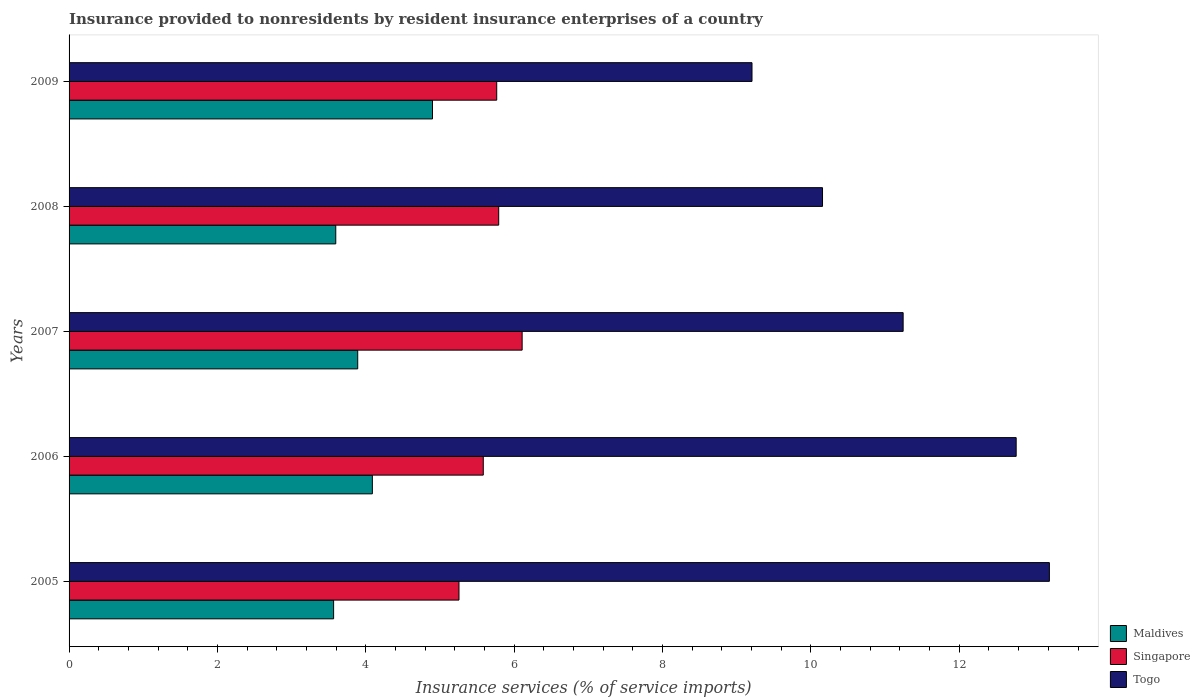How many bars are there on the 2nd tick from the top?
Offer a very short reply. 3. How many bars are there on the 2nd tick from the bottom?
Ensure brevity in your answer.  3. In how many cases, is the number of bars for a given year not equal to the number of legend labels?
Your response must be concise. 0. What is the insurance provided to nonresidents in Togo in 2005?
Your response must be concise. 13.21. Across all years, what is the maximum insurance provided to nonresidents in Maldives?
Make the answer very short. 4.9. Across all years, what is the minimum insurance provided to nonresidents in Maldives?
Ensure brevity in your answer.  3.57. What is the total insurance provided to nonresidents in Maldives in the graph?
Offer a terse response. 20.04. What is the difference between the insurance provided to nonresidents in Singapore in 2006 and that in 2008?
Give a very brief answer. -0.21. What is the difference between the insurance provided to nonresidents in Singapore in 2009 and the insurance provided to nonresidents in Togo in 2008?
Provide a short and direct response. -4.39. What is the average insurance provided to nonresidents in Maldives per year?
Provide a short and direct response. 4.01. In the year 2008, what is the difference between the insurance provided to nonresidents in Maldives and insurance provided to nonresidents in Togo?
Ensure brevity in your answer.  -6.56. What is the ratio of the insurance provided to nonresidents in Singapore in 2006 to that in 2008?
Offer a terse response. 0.96. Is the insurance provided to nonresidents in Maldives in 2005 less than that in 2006?
Make the answer very short. Yes. Is the difference between the insurance provided to nonresidents in Maldives in 2005 and 2006 greater than the difference between the insurance provided to nonresidents in Togo in 2005 and 2006?
Ensure brevity in your answer.  No. What is the difference between the highest and the second highest insurance provided to nonresidents in Singapore?
Your answer should be compact. 0.32. What is the difference between the highest and the lowest insurance provided to nonresidents in Maldives?
Make the answer very short. 1.33. In how many years, is the insurance provided to nonresidents in Singapore greater than the average insurance provided to nonresidents in Singapore taken over all years?
Your answer should be compact. 3. Is the sum of the insurance provided to nonresidents in Maldives in 2007 and 2008 greater than the maximum insurance provided to nonresidents in Singapore across all years?
Make the answer very short. Yes. What does the 2nd bar from the top in 2008 represents?
Make the answer very short. Singapore. What does the 1st bar from the bottom in 2007 represents?
Your response must be concise. Maldives. Is it the case that in every year, the sum of the insurance provided to nonresidents in Togo and insurance provided to nonresidents in Singapore is greater than the insurance provided to nonresidents in Maldives?
Your response must be concise. Yes. How many bars are there?
Give a very brief answer. 15. Are all the bars in the graph horizontal?
Keep it short and to the point. Yes. Are the values on the major ticks of X-axis written in scientific E-notation?
Give a very brief answer. No. Where does the legend appear in the graph?
Offer a very short reply. Bottom right. How many legend labels are there?
Provide a succinct answer. 3. What is the title of the graph?
Provide a short and direct response. Insurance provided to nonresidents by resident insurance enterprises of a country. Does "Sub-Saharan Africa (all income levels)" appear as one of the legend labels in the graph?
Your response must be concise. No. What is the label or title of the X-axis?
Give a very brief answer. Insurance services (% of service imports). What is the label or title of the Y-axis?
Ensure brevity in your answer.  Years. What is the Insurance services (% of service imports) of Maldives in 2005?
Your answer should be compact. 3.57. What is the Insurance services (% of service imports) of Singapore in 2005?
Make the answer very short. 5.26. What is the Insurance services (% of service imports) in Togo in 2005?
Offer a terse response. 13.21. What is the Insurance services (% of service imports) of Maldives in 2006?
Keep it short and to the point. 4.09. What is the Insurance services (% of service imports) of Singapore in 2006?
Give a very brief answer. 5.58. What is the Insurance services (% of service imports) of Togo in 2006?
Your answer should be compact. 12.77. What is the Insurance services (% of service imports) in Maldives in 2007?
Offer a terse response. 3.89. What is the Insurance services (% of service imports) in Singapore in 2007?
Offer a very short reply. 6.11. What is the Insurance services (% of service imports) in Togo in 2007?
Your answer should be very brief. 11.24. What is the Insurance services (% of service imports) in Maldives in 2008?
Make the answer very short. 3.59. What is the Insurance services (% of service imports) of Singapore in 2008?
Keep it short and to the point. 5.79. What is the Insurance services (% of service imports) in Togo in 2008?
Offer a terse response. 10.16. What is the Insurance services (% of service imports) in Maldives in 2009?
Your answer should be very brief. 4.9. What is the Insurance services (% of service imports) of Singapore in 2009?
Provide a short and direct response. 5.76. What is the Insurance services (% of service imports) in Togo in 2009?
Offer a terse response. 9.21. Across all years, what is the maximum Insurance services (% of service imports) in Maldives?
Give a very brief answer. 4.9. Across all years, what is the maximum Insurance services (% of service imports) of Singapore?
Give a very brief answer. 6.11. Across all years, what is the maximum Insurance services (% of service imports) in Togo?
Offer a terse response. 13.21. Across all years, what is the minimum Insurance services (% of service imports) of Maldives?
Ensure brevity in your answer.  3.57. Across all years, what is the minimum Insurance services (% of service imports) in Singapore?
Offer a very short reply. 5.26. Across all years, what is the minimum Insurance services (% of service imports) in Togo?
Your answer should be very brief. 9.21. What is the total Insurance services (% of service imports) in Maldives in the graph?
Ensure brevity in your answer.  20.04. What is the total Insurance services (% of service imports) in Singapore in the graph?
Offer a terse response. 28.5. What is the total Insurance services (% of service imports) of Togo in the graph?
Give a very brief answer. 56.58. What is the difference between the Insurance services (% of service imports) of Maldives in 2005 and that in 2006?
Your response must be concise. -0.52. What is the difference between the Insurance services (% of service imports) in Singapore in 2005 and that in 2006?
Your answer should be compact. -0.33. What is the difference between the Insurance services (% of service imports) in Togo in 2005 and that in 2006?
Your answer should be very brief. 0.45. What is the difference between the Insurance services (% of service imports) in Maldives in 2005 and that in 2007?
Provide a short and direct response. -0.33. What is the difference between the Insurance services (% of service imports) in Singapore in 2005 and that in 2007?
Your response must be concise. -0.85. What is the difference between the Insurance services (% of service imports) of Togo in 2005 and that in 2007?
Your answer should be compact. 1.97. What is the difference between the Insurance services (% of service imports) in Maldives in 2005 and that in 2008?
Your answer should be very brief. -0.03. What is the difference between the Insurance services (% of service imports) of Singapore in 2005 and that in 2008?
Your answer should be compact. -0.54. What is the difference between the Insurance services (% of service imports) in Togo in 2005 and that in 2008?
Keep it short and to the point. 3.06. What is the difference between the Insurance services (% of service imports) in Maldives in 2005 and that in 2009?
Keep it short and to the point. -1.33. What is the difference between the Insurance services (% of service imports) of Singapore in 2005 and that in 2009?
Provide a succinct answer. -0.51. What is the difference between the Insurance services (% of service imports) in Togo in 2005 and that in 2009?
Provide a succinct answer. 4.01. What is the difference between the Insurance services (% of service imports) in Maldives in 2006 and that in 2007?
Offer a very short reply. 0.2. What is the difference between the Insurance services (% of service imports) in Singapore in 2006 and that in 2007?
Offer a terse response. -0.52. What is the difference between the Insurance services (% of service imports) in Togo in 2006 and that in 2007?
Offer a very short reply. 1.52. What is the difference between the Insurance services (% of service imports) of Maldives in 2006 and that in 2008?
Provide a short and direct response. 0.49. What is the difference between the Insurance services (% of service imports) of Singapore in 2006 and that in 2008?
Give a very brief answer. -0.21. What is the difference between the Insurance services (% of service imports) in Togo in 2006 and that in 2008?
Provide a succinct answer. 2.61. What is the difference between the Insurance services (% of service imports) in Maldives in 2006 and that in 2009?
Provide a short and direct response. -0.81. What is the difference between the Insurance services (% of service imports) of Singapore in 2006 and that in 2009?
Your answer should be compact. -0.18. What is the difference between the Insurance services (% of service imports) of Togo in 2006 and that in 2009?
Keep it short and to the point. 3.56. What is the difference between the Insurance services (% of service imports) of Maldives in 2007 and that in 2008?
Ensure brevity in your answer.  0.3. What is the difference between the Insurance services (% of service imports) in Singapore in 2007 and that in 2008?
Make the answer very short. 0.32. What is the difference between the Insurance services (% of service imports) in Togo in 2007 and that in 2008?
Your answer should be compact. 1.09. What is the difference between the Insurance services (% of service imports) in Maldives in 2007 and that in 2009?
Offer a terse response. -1.01. What is the difference between the Insurance services (% of service imports) of Singapore in 2007 and that in 2009?
Your answer should be very brief. 0.34. What is the difference between the Insurance services (% of service imports) of Togo in 2007 and that in 2009?
Provide a succinct answer. 2.04. What is the difference between the Insurance services (% of service imports) in Maldives in 2008 and that in 2009?
Your answer should be very brief. -1.3. What is the difference between the Insurance services (% of service imports) of Singapore in 2008 and that in 2009?
Offer a very short reply. 0.03. What is the difference between the Insurance services (% of service imports) of Togo in 2008 and that in 2009?
Provide a short and direct response. 0.95. What is the difference between the Insurance services (% of service imports) in Maldives in 2005 and the Insurance services (% of service imports) in Singapore in 2006?
Your response must be concise. -2.02. What is the difference between the Insurance services (% of service imports) of Maldives in 2005 and the Insurance services (% of service imports) of Togo in 2006?
Your answer should be very brief. -9.2. What is the difference between the Insurance services (% of service imports) of Singapore in 2005 and the Insurance services (% of service imports) of Togo in 2006?
Make the answer very short. -7.51. What is the difference between the Insurance services (% of service imports) of Maldives in 2005 and the Insurance services (% of service imports) of Singapore in 2007?
Offer a very short reply. -2.54. What is the difference between the Insurance services (% of service imports) of Maldives in 2005 and the Insurance services (% of service imports) of Togo in 2007?
Offer a very short reply. -7.68. What is the difference between the Insurance services (% of service imports) of Singapore in 2005 and the Insurance services (% of service imports) of Togo in 2007?
Provide a short and direct response. -5.99. What is the difference between the Insurance services (% of service imports) in Maldives in 2005 and the Insurance services (% of service imports) in Singapore in 2008?
Keep it short and to the point. -2.23. What is the difference between the Insurance services (% of service imports) in Maldives in 2005 and the Insurance services (% of service imports) in Togo in 2008?
Give a very brief answer. -6.59. What is the difference between the Insurance services (% of service imports) in Singapore in 2005 and the Insurance services (% of service imports) in Togo in 2008?
Your answer should be compact. -4.9. What is the difference between the Insurance services (% of service imports) of Maldives in 2005 and the Insurance services (% of service imports) of Singapore in 2009?
Your answer should be very brief. -2.2. What is the difference between the Insurance services (% of service imports) in Maldives in 2005 and the Insurance services (% of service imports) in Togo in 2009?
Your answer should be compact. -5.64. What is the difference between the Insurance services (% of service imports) of Singapore in 2005 and the Insurance services (% of service imports) of Togo in 2009?
Your answer should be compact. -3.95. What is the difference between the Insurance services (% of service imports) in Maldives in 2006 and the Insurance services (% of service imports) in Singapore in 2007?
Ensure brevity in your answer.  -2.02. What is the difference between the Insurance services (% of service imports) in Maldives in 2006 and the Insurance services (% of service imports) in Togo in 2007?
Provide a short and direct response. -7.15. What is the difference between the Insurance services (% of service imports) in Singapore in 2006 and the Insurance services (% of service imports) in Togo in 2007?
Your answer should be compact. -5.66. What is the difference between the Insurance services (% of service imports) of Maldives in 2006 and the Insurance services (% of service imports) of Singapore in 2008?
Offer a terse response. -1.7. What is the difference between the Insurance services (% of service imports) of Maldives in 2006 and the Insurance services (% of service imports) of Togo in 2008?
Ensure brevity in your answer.  -6.07. What is the difference between the Insurance services (% of service imports) in Singapore in 2006 and the Insurance services (% of service imports) in Togo in 2008?
Your response must be concise. -4.57. What is the difference between the Insurance services (% of service imports) in Maldives in 2006 and the Insurance services (% of service imports) in Singapore in 2009?
Offer a terse response. -1.68. What is the difference between the Insurance services (% of service imports) of Maldives in 2006 and the Insurance services (% of service imports) of Togo in 2009?
Your answer should be compact. -5.12. What is the difference between the Insurance services (% of service imports) of Singapore in 2006 and the Insurance services (% of service imports) of Togo in 2009?
Your response must be concise. -3.62. What is the difference between the Insurance services (% of service imports) of Maldives in 2007 and the Insurance services (% of service imports) of Singapore in 2008?
Provide a short and direct response. -1.9. What is the difference between the Insurance services (% of service imports) in Maldives in 2007 and the Insurance services (% of service imports) in Togo in 2008?
Give a very brief answer. -6.27. What is the difference between the Insurance services (% of service imports) in Singapore in 2007 and the Insurance services (% of service imports) in Togo in 2008?
Your answer should be very brief. -4.05. What is the difference between the Insurance services (% of service imports) in Maldives in 2007 and the Insurance services (% of service imports) in Singapore in 2009?
Keep it short and to the point. -1.87. What is the difference between the Insurance services (% of service imports) of Maldives in 2007 and the Insurance services (% of service imports) of Togo in 2009?
Provide a short and direct response. -5.31. What is the difference between the Insurance services (% of service imports) in Singapore in 2007 and the Insurance services (% of service imports) in Togo in 2009?
Provide a short and direct response. -3.1. What is the difference between the Insurance services (% of service imports) of Maldives in 2008 and the Insurance services (% of service imports) of Singapore in 2009?
Your response must be concise. -2.17. What is the difference between the Insurance services (% of service imports) of Maldives in 2008 and the Insurance services (% of service imports) of Togo in 2009?
Your answer should be compact. -5.61. What is the difference between the Insurance services (% of service imports) of Singapore in 2008 and the Insurance services (% of service imports) of Togo in 2009?
Offer a very short reply. -3.41. What is the average Insurance services (% of service imports) of Maldives per year?
Your answer should be compact. 4.01. What is the average Insurance services (% of service imports) in Singapore per year?
Keep it short and to the point. 5.7. What is the average Insurance services (% of service imports) of Togo per year?
Your response must be concise. 11.32. In the year 2005, what is the difference between the Insurance services (% of service imports) of Maldives and Insurance services (% of service imports) of Singapore?
Give a very brief answer. -1.69. In the year 2005, what is the difference between the Insurance services (% of service imports) of Maldives and Insurance services (% of service imports) of Togo?
Your response must be concise. -9.65. In the year 2005, what is the difference between the Insurance services (% of service imports) of Singapore and Insurance services (% of service imports) of Togo?
Provide a short and direct response. -7.96. In the year 2006, what is the difference between the Insurance services (% of service imports) of Maldives and Insurance services (% of service imports) of Singapore?
Your answer should be compact. -1.5. In the year 2006, what is the difference between the Insurance services (% of service imports) in Maldives and Insurance services (% of service imports) in Togo?
Make the answer very short. -8.68. In the year 2006, what is the difference between the Insurance services (% of service imports) in Singapore and Insurance services (% of service imports) in Togo?
Keep it short and to the point. -7.18. In the year 2007, what is the difference between the Insurance services (% of service imports) of Maldives and Insurance services (% of service imports) of Singapore?
Offer a very short reply. -2.22. In the year 2007, what is the difference between the Insurance services (% of service imports) of Maldives and Insurance services (% of service imports) of Togo?
Your answer should be compact. -7.35. In the year 2007, what is the difference between the Insurance services (% of service imports) of Singapore and Insurance services (% of service imports) of Togo?
Make the answer very short. -5.14. In the year 2008, what is the difference between the Insurance services (% of service imports) in Maldives and Insurance services (% of service imports) in Singapore?
Your response must be concise. -2.2. In the year 2008, what is the difference between the Insurance services (% of service imports) of Maldives and Insurance services (% of service imports) of Togo?
Your response must be concise. -6.56. In the year 2008, what is the difference between the Insurance services (% of service imports) in Singapore and Insurance services (% of service imports) in Togo?
Make the answer very short. -4.36. In the year 2009, what is the difference between the Insurance services (% of service imports) in Maldives and Insurance services (% of service imports) in Singapore?
Provide a short and direct response. -0.87. In the year 2009, what is the difference between the Insurance services (% of service imports) in Maldives and Insurance services (% of service imports) in Togo?
Your answer should be compact. -4.31. In the year 2009, what is the difference between the Insurance services (% of service imports) in Singapore and Insurance services (% of service imports) in Togo?
Offer a terse response. -3.44. What is the ratio of the Insurance services (% of service imports) in Maldives in 2005 to that in 2006?
Offer a very short reply. 0.87. What is the ratio of the Insurance services (% of service imports) in Singapore in 2005 to that in 2006?
Offer a very short reply. 0.94. What is the ratio of the Insurance services (% of service imports) of Togo in 2005 to that in 2006?
Make the answer very short. 1.04. What is the ratio of the Insurance services (% of service imports) of Maldives in 2005 to that in 2007?
Your answer should be very brief. 0.92. What is the ratio of the Insurance services (% of service imports) in Singapore in 2005 to that in 2007?
Provide a short and direct response. 0.86. What is the ratio of the Insurance services (% of service imports) in Togo in 2005 to that in 2007?
Ensure brevity in your answer.  1.18. What is the ratio of the Insurance services (% of service imports) of Maldives in 2005 to that in 2008?
Your response must be concise. 0.99. What is the ratio of the Insurance services (% of service imports) in Singapore in 2005 to that in 2008?
Offer a terse response. 0.91. What is the ratio of the Insurance services (% of service imports) of Togo in 2005 to that in 2008?
Your answer should be compact. 1.3. What is the ratio of the Insurance services (% of service imports) of Maldives in 2005 to that in 2009?
Offer a very short reply. 0.73. What is the ratio of the Insurance services (% of service imports) in Singapore in 2005 to that in 2009?
Offer a terse response. 0.91. What is the ratio of the Insurance services (% of service imports) in Togo in 2005 to that in 2009?
Offer a terse response. 1.44. What is the ratio of the Insurance services (% of service imports) in Maldives in 2006 to that in 2007?
Your answer should be compact. 1.05. What is the ratio of the Insurance services (% of service imports) in Singapore in 2006 to that in 2007?
Make the answer very short. 0.91. What is the ratio of the Insurance services (% of service imports) of Togo in 2006 to that in 2007?
Provide a short and direct response. 1.14. What is the ratio of the Insurance services (% of service imports) in Maldives in 2006 to that in 2008?
Offer a very short reply. 1.14. What is the ratio of the Insurance services (% of service imports) of Singapore in 2006 to that in 2008?
Provide a short and direct response. 0.96. What is the ratio of the Insurance services (% of service imports) in Togo in 2006 to that in 2008?
Ensure brevity in your answer.  1.26. What is the ratio of the Insurance services (% of service imports) in Maldives in 2006 to that in 2009?
Offer a terse response. 0.83. What is the ratio of the Insurance services (% of service imports) of Singapore in 2006 to that in 2009?
Offer a terse response. 0.97. What is the ratio of the Insurance services (% of service imports) in Togo in 2006 to that in 2009?
Provide a succinct answer. 1.39. What is the ratio of the Insurance services (% of service imports) of Maldives in 2007 to that in 2008?
Make the answer very short. 1.08. What is the ratio of the Insurance services (% of service imports) in Singapore in 2007 to that in 2008?
Keep it short and to the point. 1.05. What is the ratio of the Insurance services (% of service imports) in Togo in 2007 to that in 2008?
Provide a short and direct response. 1.11. What is the ratio of the Insurance services (% of service imports) in Maldives in 2007 to that in 2009?
Provide a succinct answer. 0.79. What is the ratio of the Insurance services (% of service imports) in Singapore in 2007 to that in 2009?
Offer a terse response. 1.06. What is the ratio of the Insurance services (% of service imports) of Togo in 2007 to that in 2009?
Your answer should be compact. 1.22. What is the ratio of the Insurance services (% of service imports) of Maldives in 2008 to that in 2009?
Provide a short and direct response. 0.73. What is the ratio of the Insurance services (% of service imports) in Singapore in 2008 to that in 2009?
Offer a terse response. 1. What is the ratio of the Insurance services (% of service imports) in Togo in 2008 to that in 2009?
Your response must be concise. 1.1. What is the difference between the highest and the second highest Insurance services (% of service imports) of Maldives?
Offer a terse response. 0.81. What is the difference between the highest and the second highest Insurance services (% of service imports) in Singapore?
Your response must be concise. 0.32. What is the difference between the highest and the second highest Insurance services (% of service imports) in Togo?
Provide a short and direct response. 0.45. What is the difference between the highest and the lowest Insurance services (% of service imports) in Maldives?
Your answer should be very brief. 1.33. What is the difference between the highest and the lowest Insurance services (% of service imports) of Singapore?
Your answer should be compact. 0.85. What is the difference between the highest and the lowest Insurance services (% of service imports) of Togo?
Give a very brief answer. 4.01. 